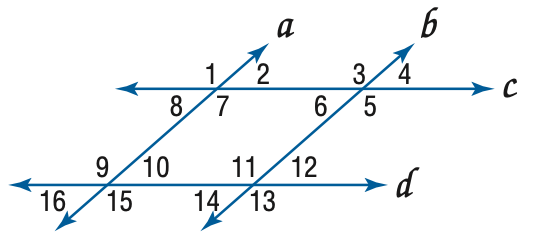Answer the mathemtical geometry problem and directly provide the correct option letter.
Question: In the figure, a \parallel b, c \parallel d, and m \angle 4 = 57. Find the measure of \angle 10.
Choices: A: 57 B: 113 C: 123 D: 133 A 